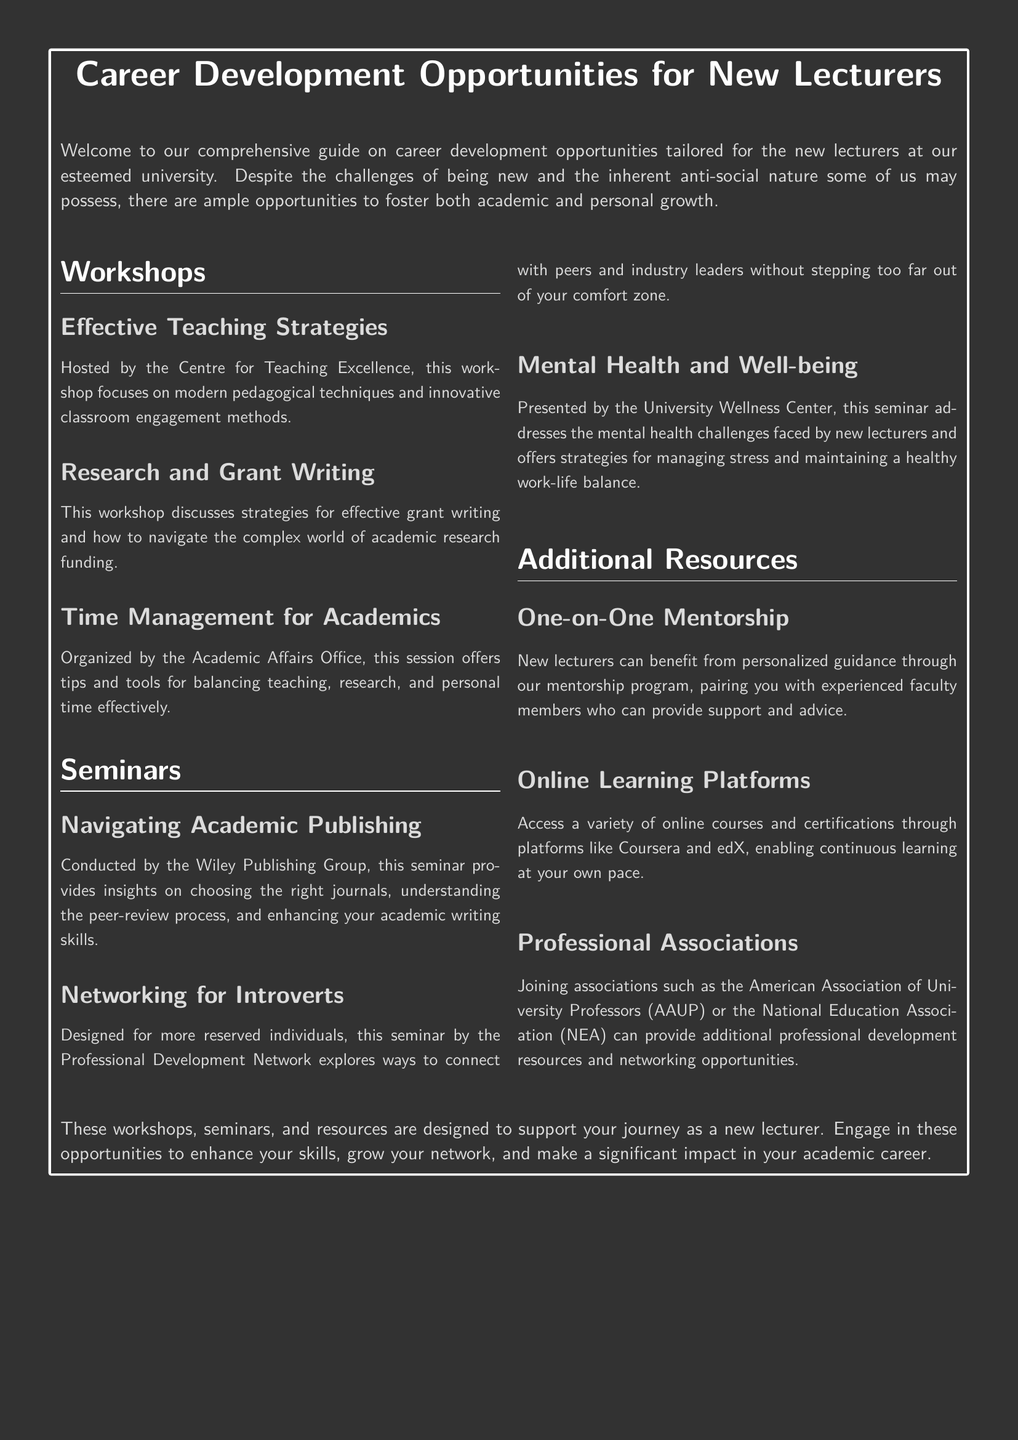What is the name of the workshop that focuses on pedagogical techniques? The workshop that focuses on modern pedagogical techniques is titled "Effective Teaching Strategies."
Answer: Effective Teaching Strategies Who hosts the "Research and Grant Writing" workshop? The workshop on research and grant writing is hosted by the Centre for Teaching Excellence.
Answer: Centre for Teaching Excellence How many seminars are mentioned in the document? There are three seminars listed in the document: "Navigating Academic Publishing," "Networking for Introverts," and "Mental Health and Well-being."
Answer: 3 What resource allows for personalized guidance? The resource that provides personalized guidance is the "One-on-One Mentorship" program.
Answer: One-on-One Mentorship Which seminar is designed for reserved individuals? The seminar specifically designed for reserved individuals is titled "Networking for Introverts."
Answer: Networking for Introverts What online platforms are mentioned for continuous learning? The online platforms mentioned for continuous learning are Coursera and edX.
Answer: Coursera and edX Which office organizes the "Time Management for Academics" session? The "Time Management for Academics" session is organized by the Academic Affairs Office.
Answer: Academic Affairs Office What is the primary focus of the "Mental Health and Well-being" seminar? The seminar's primary focus is to address the mental health challenges faced by new lecturers and offer strategies for managing stress.
Answer: Mental health challenges and stress management What professional associations are suggested for networking opportunities? The suggested professional associations include the American Association of University Professors (AAUP) and the National Education Association (NEA).
Answer: AAUP and NEA 